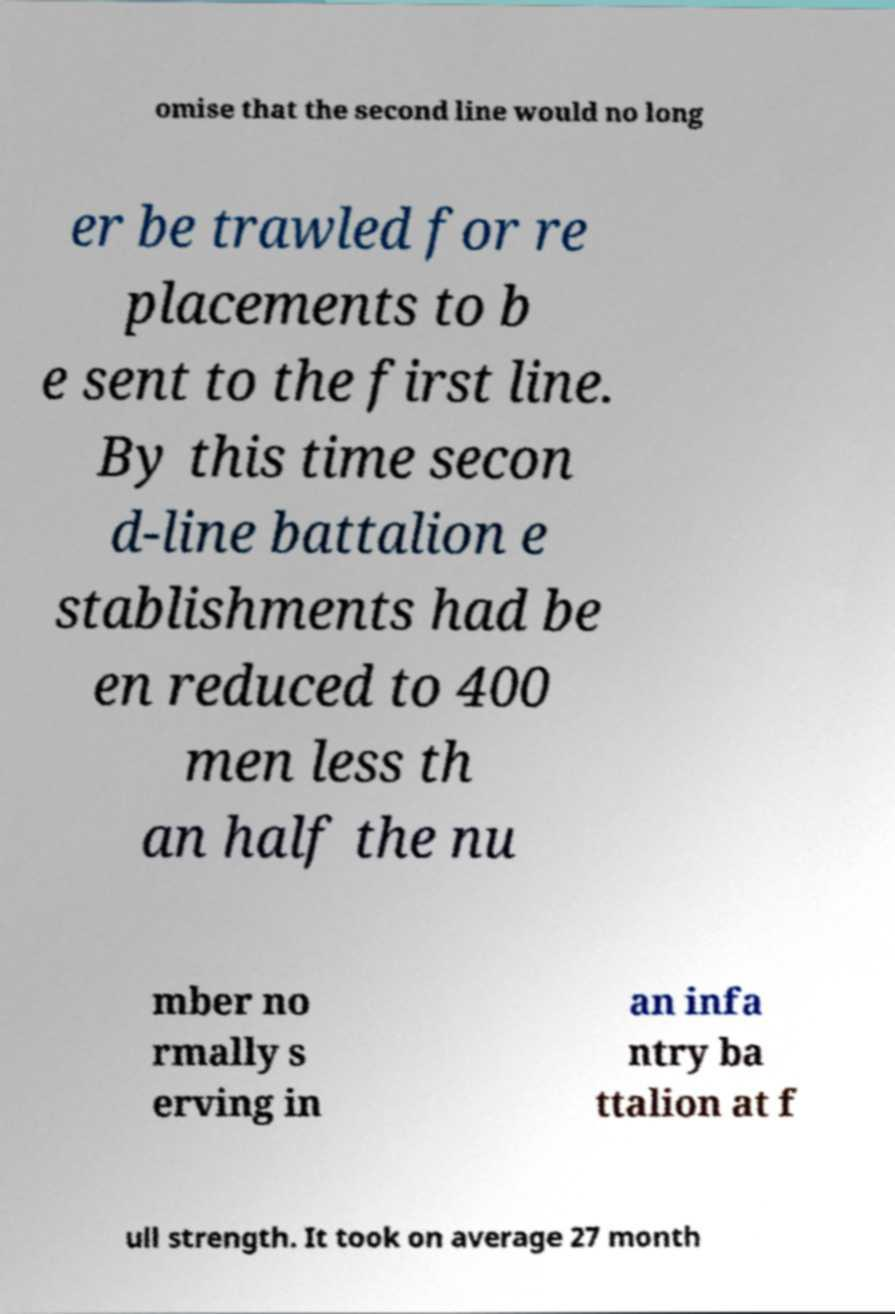What messages or text are displayed in this image? I need them in a readable, typed format. omise that the second line would no long er be trawled for re placements to b e sent to the first line. By this time secon d-line battalion e stablishments had be en reduced to 400 men less th an half the nu mber no rmally s erving in an infa ntry ba ttalion at f ull strength. It took on average 27 month 